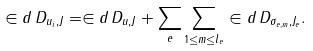Convert formula to latex. <formula><loc_0><loc_0><loc_500><loc_500>\in d \, D _ { u _ { i } , J } = \in d \, D _ { u , J } + \sum _ { e } \sum _ { 1 \leq m \leq l _ { e } } \in d \, D _ { \sigma _ { e , m } , J _ { e } } .</formula> 